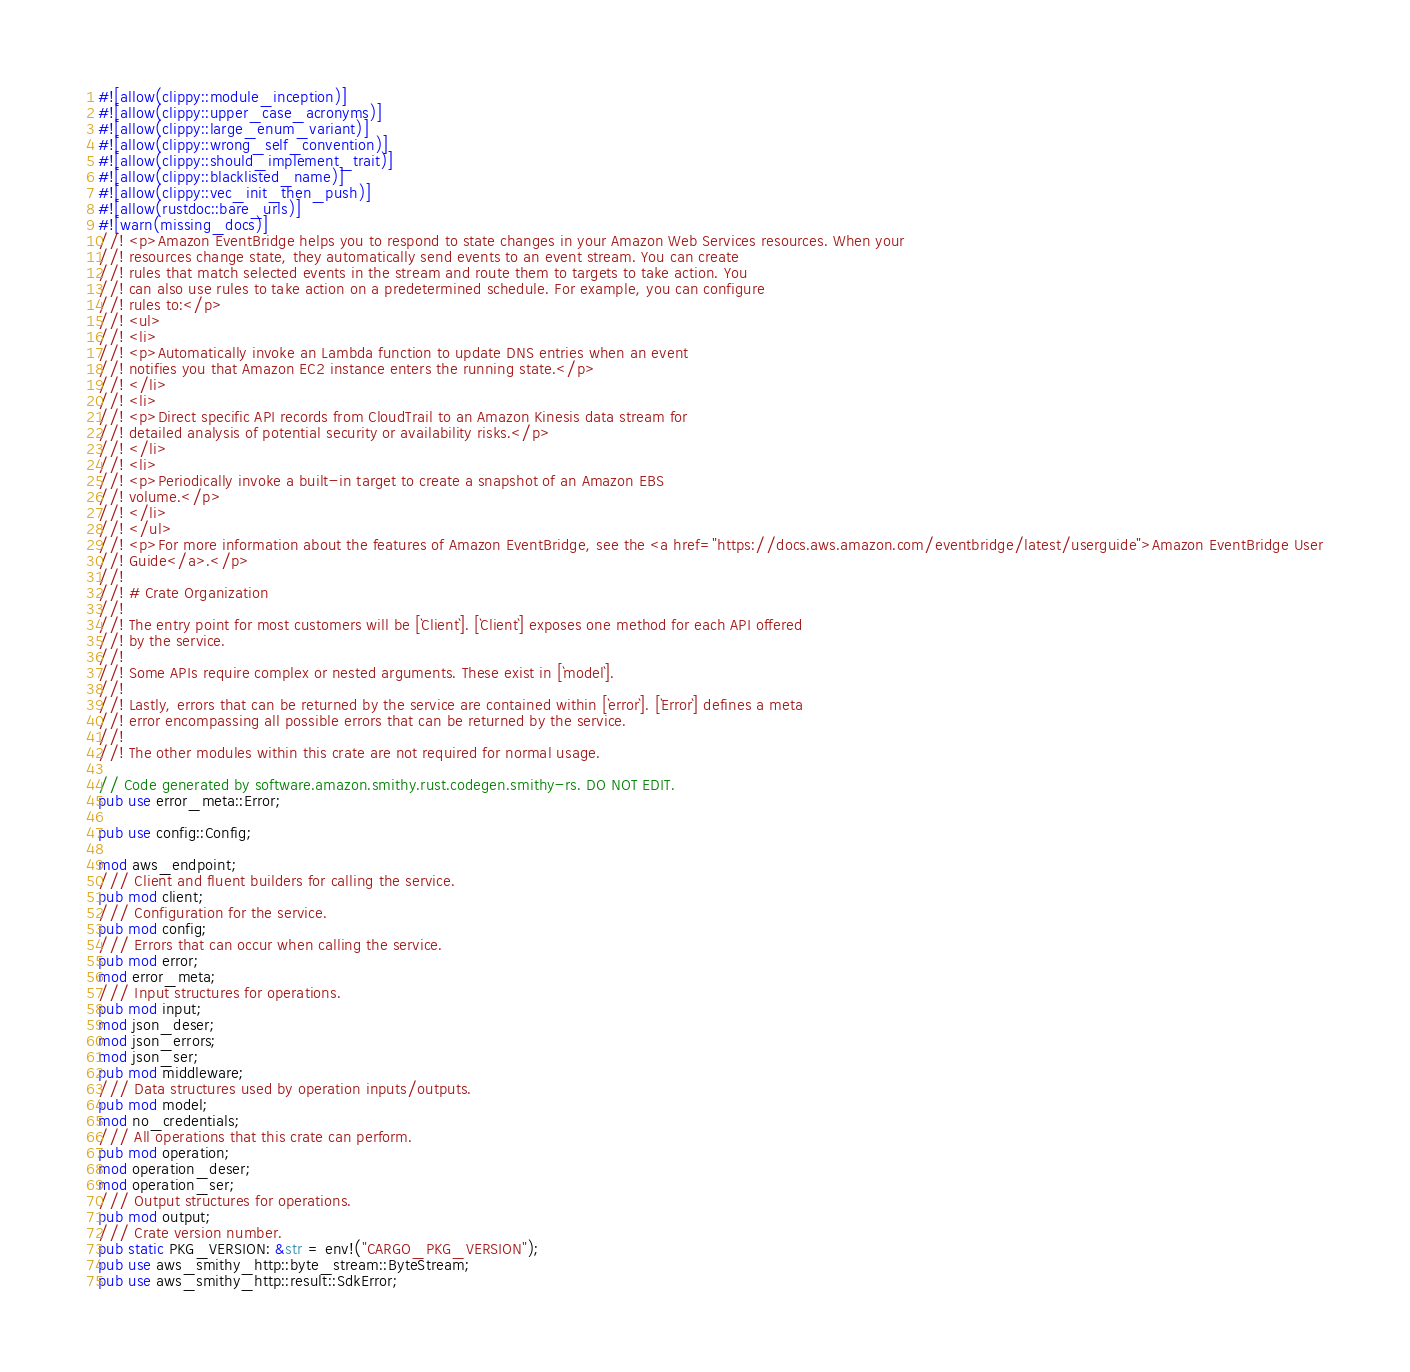Convert code to text. <code><loc_0><loc_0><loc_500><loc_500><_Rust_>#![allow(clippy::module_inception)]
#![allow(clippy::upper_case_acronyms)]
#![allow(clippy::large_enum_variant)]
#![allow(clippy::wrong_self_convention)]
#![allow(clippy::should_implement_trait)]
#![allow(clippy::blacklisted_name)]
#![allow(clippy::vec_init_then_push)]
#![allow(rustdoc::bare_urls)]
#![warn(missing_docs)]
//! <p>Amazon EventBridge helps you to respond to state changes in your Amazon Web Services resources. When your
//! resources change state, they automatically send events to an event stream. You can create
//! rules that match selected events in the stream and route them to targets to take action. You
//! can also use rules to take action on a predetermined schedule. For example, you can configure
//! rules to:</p>
//! <ul>
//! <li>
//! <p>Automatically invoke an Lambda function to update DNS entries when an event
//! notifies you that Amazon EC2 instance enters the running state.</p>
//! </li>
//! <li>
//! <p>Direct specific API records from CloudTrail to an Amazon Kinesis data stream for
//! detailed analysis of potential security or availability risks.</p>
//! </li>
//! <li>
//! <p>Periodically invoke a built-in target to create a snapshot of an Amazon EBS
//! volume.</p>
//! </li>
//! </ul>
//! <p>For more information about the features of Amazon EventBridge, see the <a href="https://docs.aws.amazon.com/eventbridge/latest/userguide">Amazon EventBridge User
//! Guide</a>.</p>
//!
//! # Crate Organization
//!
//! The entry point for most customers will be [`Client`]. [`Client`] exposes one method for each API offered
//! by the service.
//!
//! Some APIs require complex or nested arguments. These exist in [`model`].
//!
//! Lastly, errors that can be returned by the service are contained within [`error`]. [`Error`] defines a meta
//! error encompassing all possible errors that can be returned by the service.
//!
//! The other modules within this crate are not required for normal usage.

// Code generated by software.amazon.smithy.rust.codegen.smithy-rs. DO NOT EDIT.
pub use error_meta::Error;

pub use config::Config;

mod aws_endpoint;
/// Client and fluent builders for calling the service.
pub mod client;
/// Configuration for the service.
pub mod config;
/// Errors that can occur when calling the service.
pub mod error;
mod error_meta;
/// Input structures for operations.
pub mod input;
mod json_deser;
mod json_errors;
mod json_ser;
pub mod middleware;
/// Data structures used by operation inputs/outputs.
pub mod model;
mod no_credentials;
/// All operations that this crate can perform.
pub mod operation;
mod operation_deser;
mod operation_ser;
/// Output structures for operations.
pub mod output;
/// Crate version number.
pub static PKG_VERSION: &str = env!("CARGO_PKG_VERSION");
pub use aws_smithy_http::byte_stream::ByteStream;
pub use aws_smithy_http::result::SdkError;</code> 